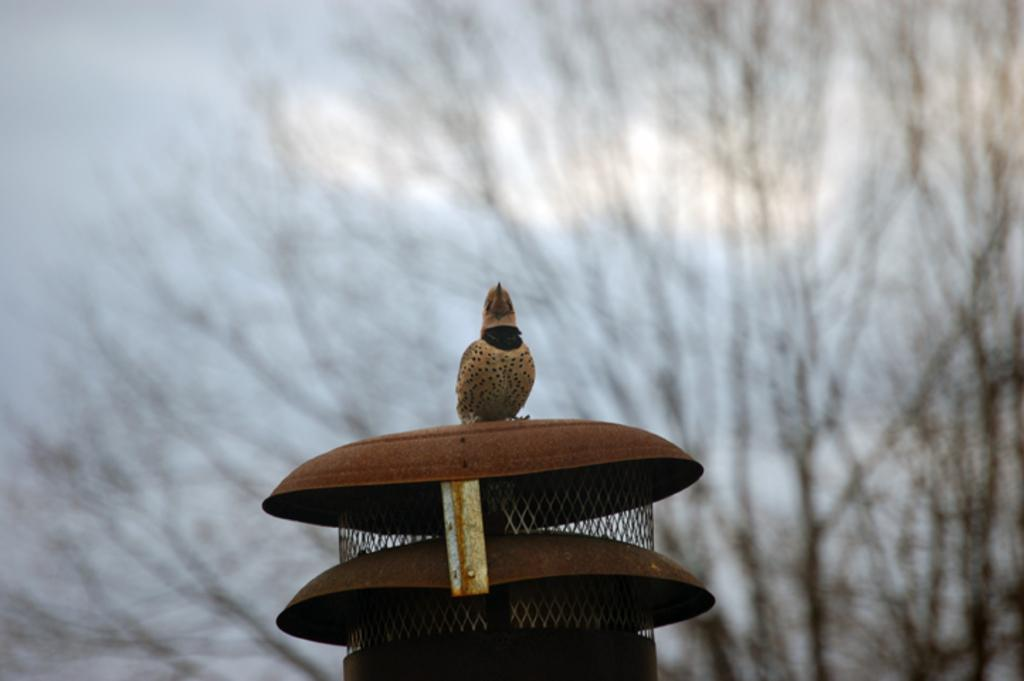What type of structure can be seen in the image? There is a metal-like structure in the image. Is there any living creature on the structure? Yes, a bird is sitting on the structure. What other natural element is visible in the image? There is a tree visible in the image. What type of clover can be seen growing near the tree in the image? There is no clover visible in the image; only the metal-like structure, the bird, and the tree are present. 